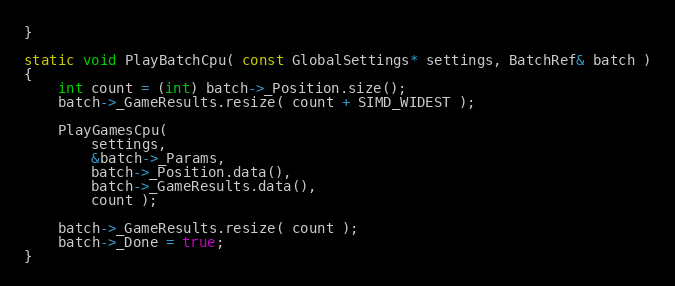<code> <loc_0><loc_0><loc_500><loc_500><_C_>}

static void PlayBatchCpu( const GlobalSettings* settings, BatchRef& batch )
{
    int count = (int) batch->_Position.size();
    batch->_GameResults.resize( count + SIMD_WIDEST );

    PlayGamesCpu(
        settings,
        &batch->_Params,
        batch->_Position.data(),
        batch->_GameResults.data(),
        count );

    batch->_GameResults.resize( count );
    batch->_Done = true;
}


</code> 